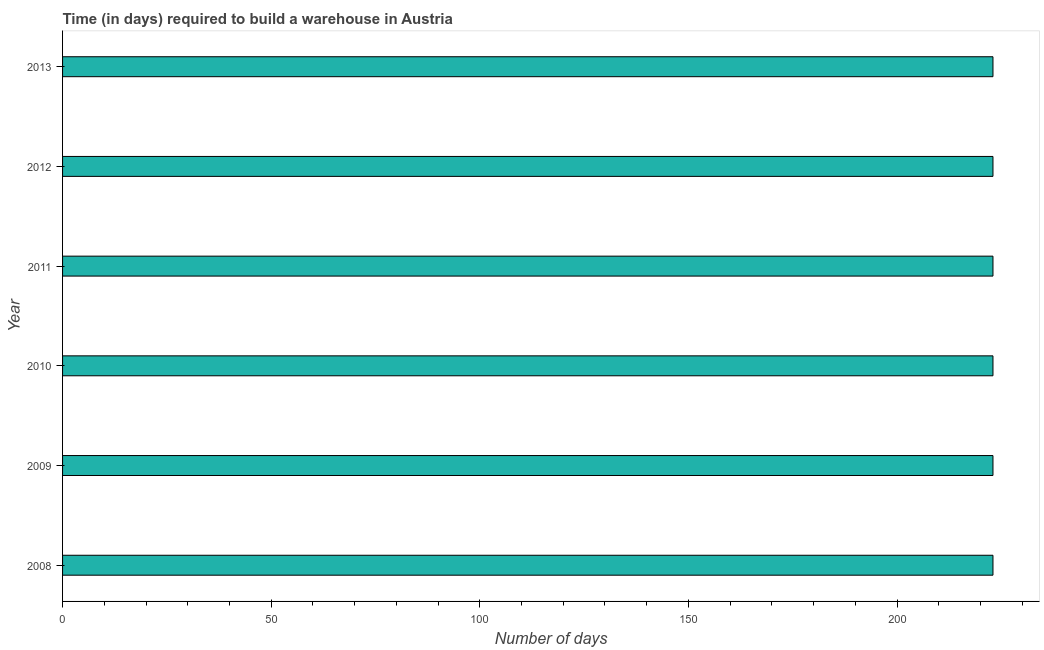Does the graph contain any zero values?
Offer a terse response. No. Does the graph contain grids?
Your response must be concise. No. What is the title of the graph?
Keep it short and to the point. Time (in days) required to build a warehouse in Austria. What is the label or title of the X-axis?
Your answer should be very brief. Number of days. What is the label or title of the Y-axis?
Your answer should be very brief. Year. What is the time required to build a warehouse in 2010?
Offer a terse response. 223. Across all years, what is the maximum time required to build a warehouse?
Your answer should be very brief. 223. Across all years, what is the minimum time required to build a warehouse?
Provide a short and direct response. 223. In which year was the time required to build a warehouse maximum?
Provide a short and direct response. 2008. What is the sum of the time required to build a warehouse?
Make the answer very short. 1338. What is the difference between the time required to build a warehouse in 2011 and 2013?
Your answer should be compact. 0. What is the average time required to build a warehouse per year?
Give a very brief answer. 223. What is the median time required to build a warehouse?
Your answer should be compact. 223. In how many years, is the time required to build a warehouse greater than 10 days?
Keep it short and to the point. 6. Do a majority of the years between 2008 and 2010 (inclusive) have time required to build a warehouse greater than 30 days?
Offer a terse response. Yes. Is the time required to build a warehouse in 2010 less than that in 2012?
Make the answer very short. No. Is the sum of the time required to build a warehouse in 2009 and 2011 greater than the maximum time required to build a warehouse across all years?
Make the answer very short. Yes. What is the difference between the highest and the lowest time required to build a warehouse?
Provide a succinct answer. 0. How many bars are there?
Offer a terse response. 6. How many years are there in the graph?
Keep it short and to the point. 6. Are the values on the major ticks of X-axis written in scientific E-notation?
Your answer should be compact. No. What is the Number of days of 2008?
Your response must be concise. 223. What is the Number of days of 2009?
Offer a terse response. 223. What is the Number of days of 2010?
Give a very brief answer. 223. What is the Number of days in 2011?
Offer a terse response. 223. What is the Number of days in 2012?
Offer a very short reply. 223. What is the Number of days in 2013?
Offer a very short reply. 223. What is the difference between the Number of days in 2008 and 2009?
Your answer should be compact. 0. What is the difference between the Number of days in 2008 and 2011?
Keep it short and to the point. 0. What is the difference between the Number of days in 2008 and 2012?
Provide a succinct answer. 0. What is the difference between the Number of days in 2009 and 2011?
Give a very brief answer. 0. What is the difference between the Number of days in 2009 and 2012?
Offer a very short reply. 0. What is the difference between the Number of days in 2009 and 2013?
Provide a succinct answer. 0. What is the difference between the Number of days in 2010 and 2013?
Make the answer very short. 0. What is the ratio of the Number of days in 2008 to that in 2009?
Your answer should be very brief. 1. What is the ratio of the Number of days in 2008 to that in 2010?
Keep it short and to the point. 1. What is the ratio of the Number of days in 2008 to that in 2012?
Offer a terse response. 1. What is the ratio of the Number of days in 2008 to that in 2013?
Make the answer very short. 1. What is the ratio of the Number of days in 2009 to that in 2012?
Your answer should be very brief. 1. What is the ratio of the Number of days in 2009 to that in 2013?
Keep it short and to the point. 1. What is the ratio of the Number of days in 2010 to that in 2011?
Offer a terse response. 1. What is the ratio of the Number of days in 2010 to that in 2012?
Provide a succinct answer. 1. What is the ratio of the Number of days in 2010 to that in 2013?
Provide a succinct answer. 1. What is the ratio of the Number of days in 2011 to that in 2013?
Your response must be concise. 1. 